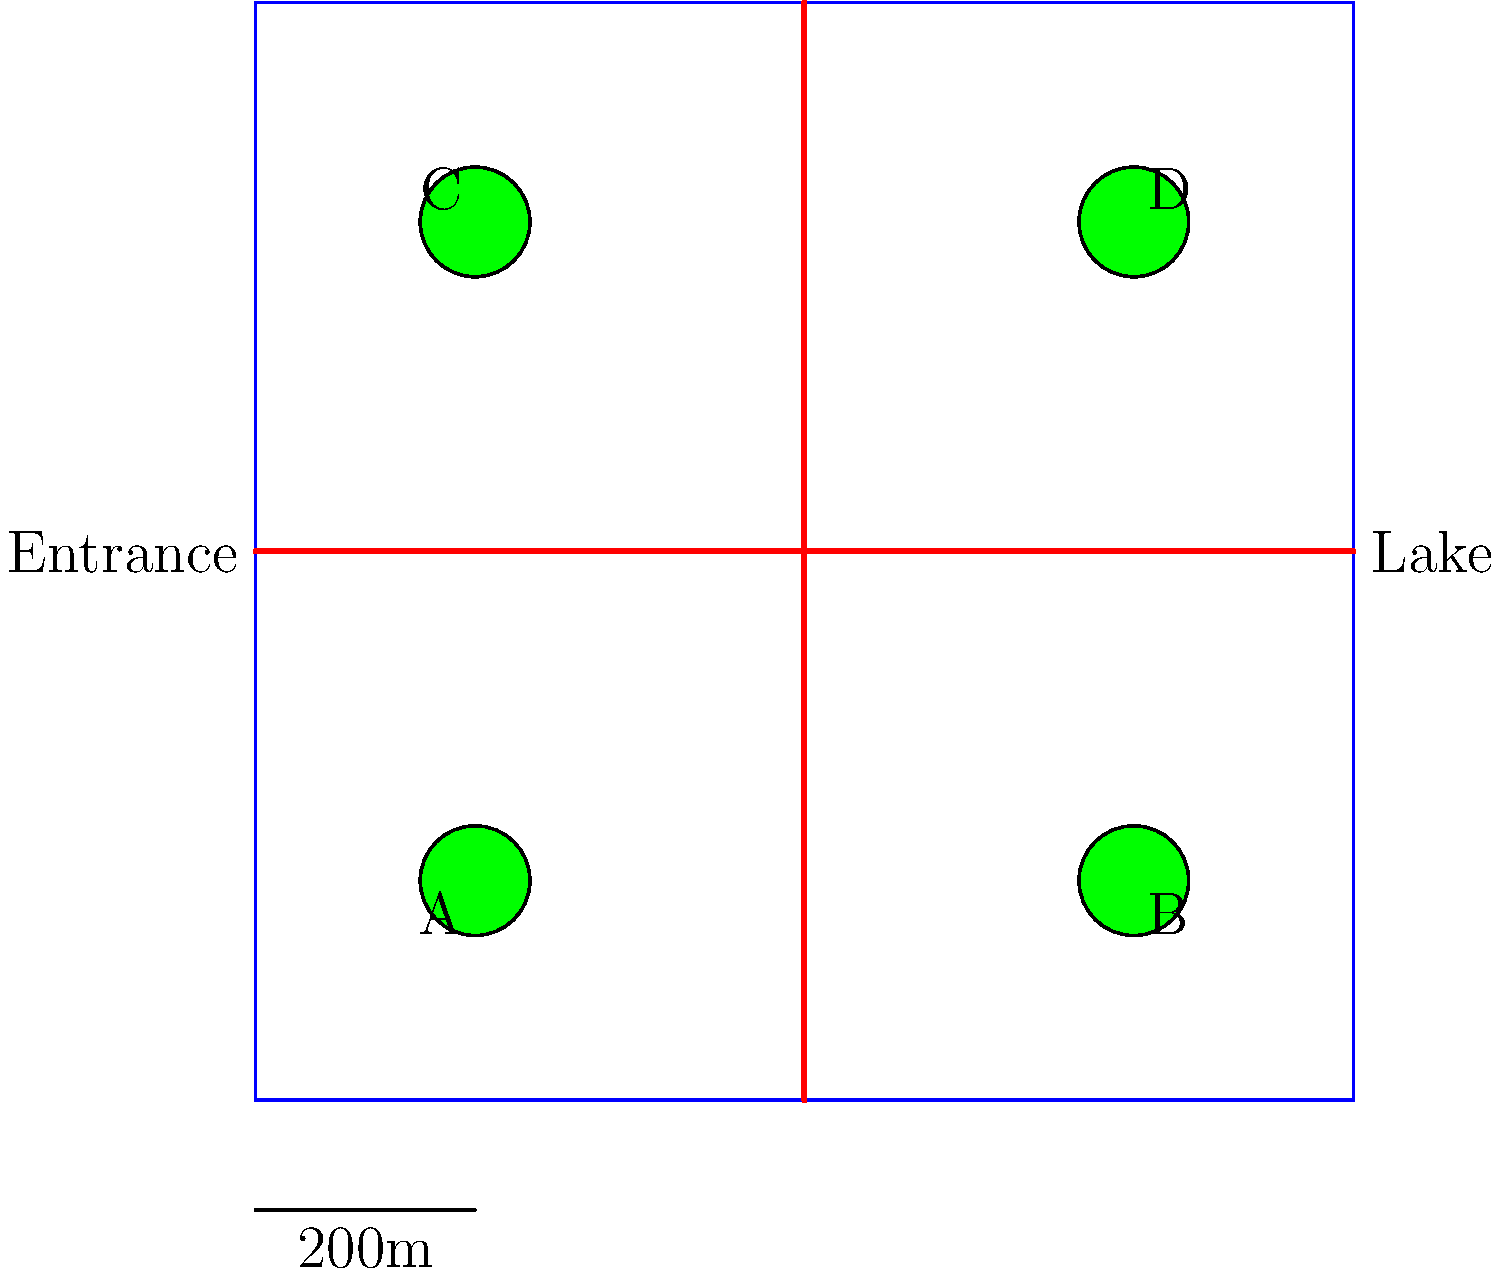You're planning a family bike trip to a campground with your child. The campground layout is shown above, where red lines represent bike paths and green circles represent campsites. If you want to choose a campsite that minimizes the bike ride distance to both the entrance and the lake for your child's safety, which campsite should you select? To determine the best campsite, we need to consider the distance from each site to both the entrance and the lake. Let's analyze each campsite:

1. Campsite A (2,2):
   - Distance to entrance: 3 units (2 right, 3 up)
   - Distance to lake: 8 units (8 right)
   - Total distance: 11 units

2. Campsite B (8,2):
   - Distance to entrance: 3 units (3 up)
   - Distance to lake: 2 units (2 right)
   - Total distance: 5 units

3. Campsite C (2,8):
   - Distance to entrance: 3 units (2 right, 3 down)
   - Distance to lake: 8 units (8 right)
   - Total distance: 11 units

4. Campsite D (8,8):
   - Distance to entrance: 3 units (3 down)
   - Distance to lake: 2 units (2 right)
   - Total distance: 5 units

Campsites B and D both have the shortest total distance of 5 units. However, campsite B is slightly closer to the entrance, which could be beneficial for easier access and safety.

Therefore, the best campsite to choose for minimizing the bike ride distance to both the entrance and the lake is campsite B.
Answer: Campsite B 